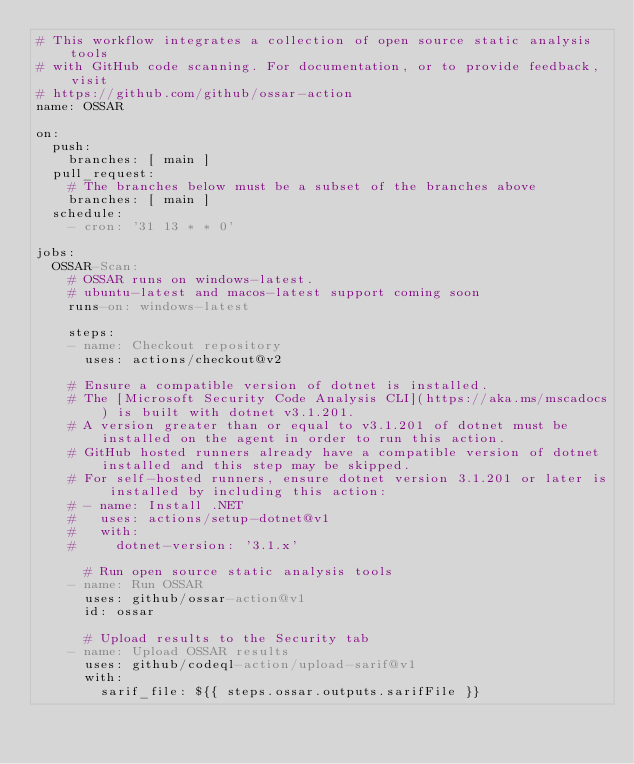Convert code to text. <code><loc_0><loc_0><loc_500><loc_500><_YAML_># This workflow integrates a collection of open source static analysis tools
# with GitHub code scanning. For documentation, or to provide feedback, visit
# https://github.com/github/ossar-action
name: OSSAR

on:
  push:
    branches: [ main ]
  pull_request:
    # The branches below must be a subset of the branches above
    branches: [ main ]
  schedule:
    - cron: '31 13 * * 0'

jobs:
  OSSAR-Scan:
    # OSSAR runs on windows-latest.
    # ubuntu-latest and macos-latest support coming soon
    runs-on: windows-latest

    steps:
    - name: Checkout repository
      uses: actions/checkout@v2

    # Ensure a compatible version of dotnet is installed.
    # The [Microsoft Security Code Analysis CLI](https://aka.ms/mscadocs) is built with dotnet v3.1.201.
    # A version greater than or equal to v3.1.201 of dotnet must be installed on the agent in order to run this action.
    # GitHub hosted runners already have a compatible version of dotnet installed and this step may be skipped.
    # For self-hosted runners, ensure dotnet version 3.1.201 or later is installed by including this action:
    # - name: Install .NET
    #   uses: actions/setup-dotnet@v1
    #   with:
    #     dotnet-version: '3.1.x'

      # Run open source static analysis tools
    - name: Run OSSAR
      uses: github/ossar-action@v1
      id: ossar

      # Upload results to the Security tab
    - name: Upload OSSAR results
      uses: github/codeql-action/upload-sarif@v1
      with:
        sarif_file: ${{ steps.ossar.outputs.sarifFile }}
</code> 